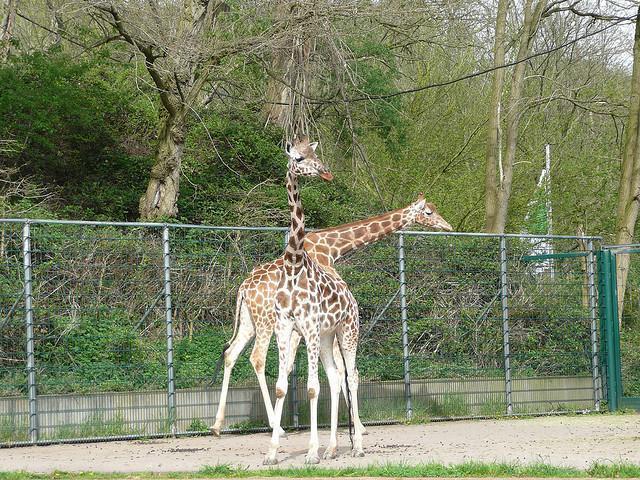How many giraffes are there?
Give a very brief answer. 2. How many giraffes are in the picture?
Give a very brief answer. 2. How many umbrellas are near the trees?
Give a very brief answer. 0. 